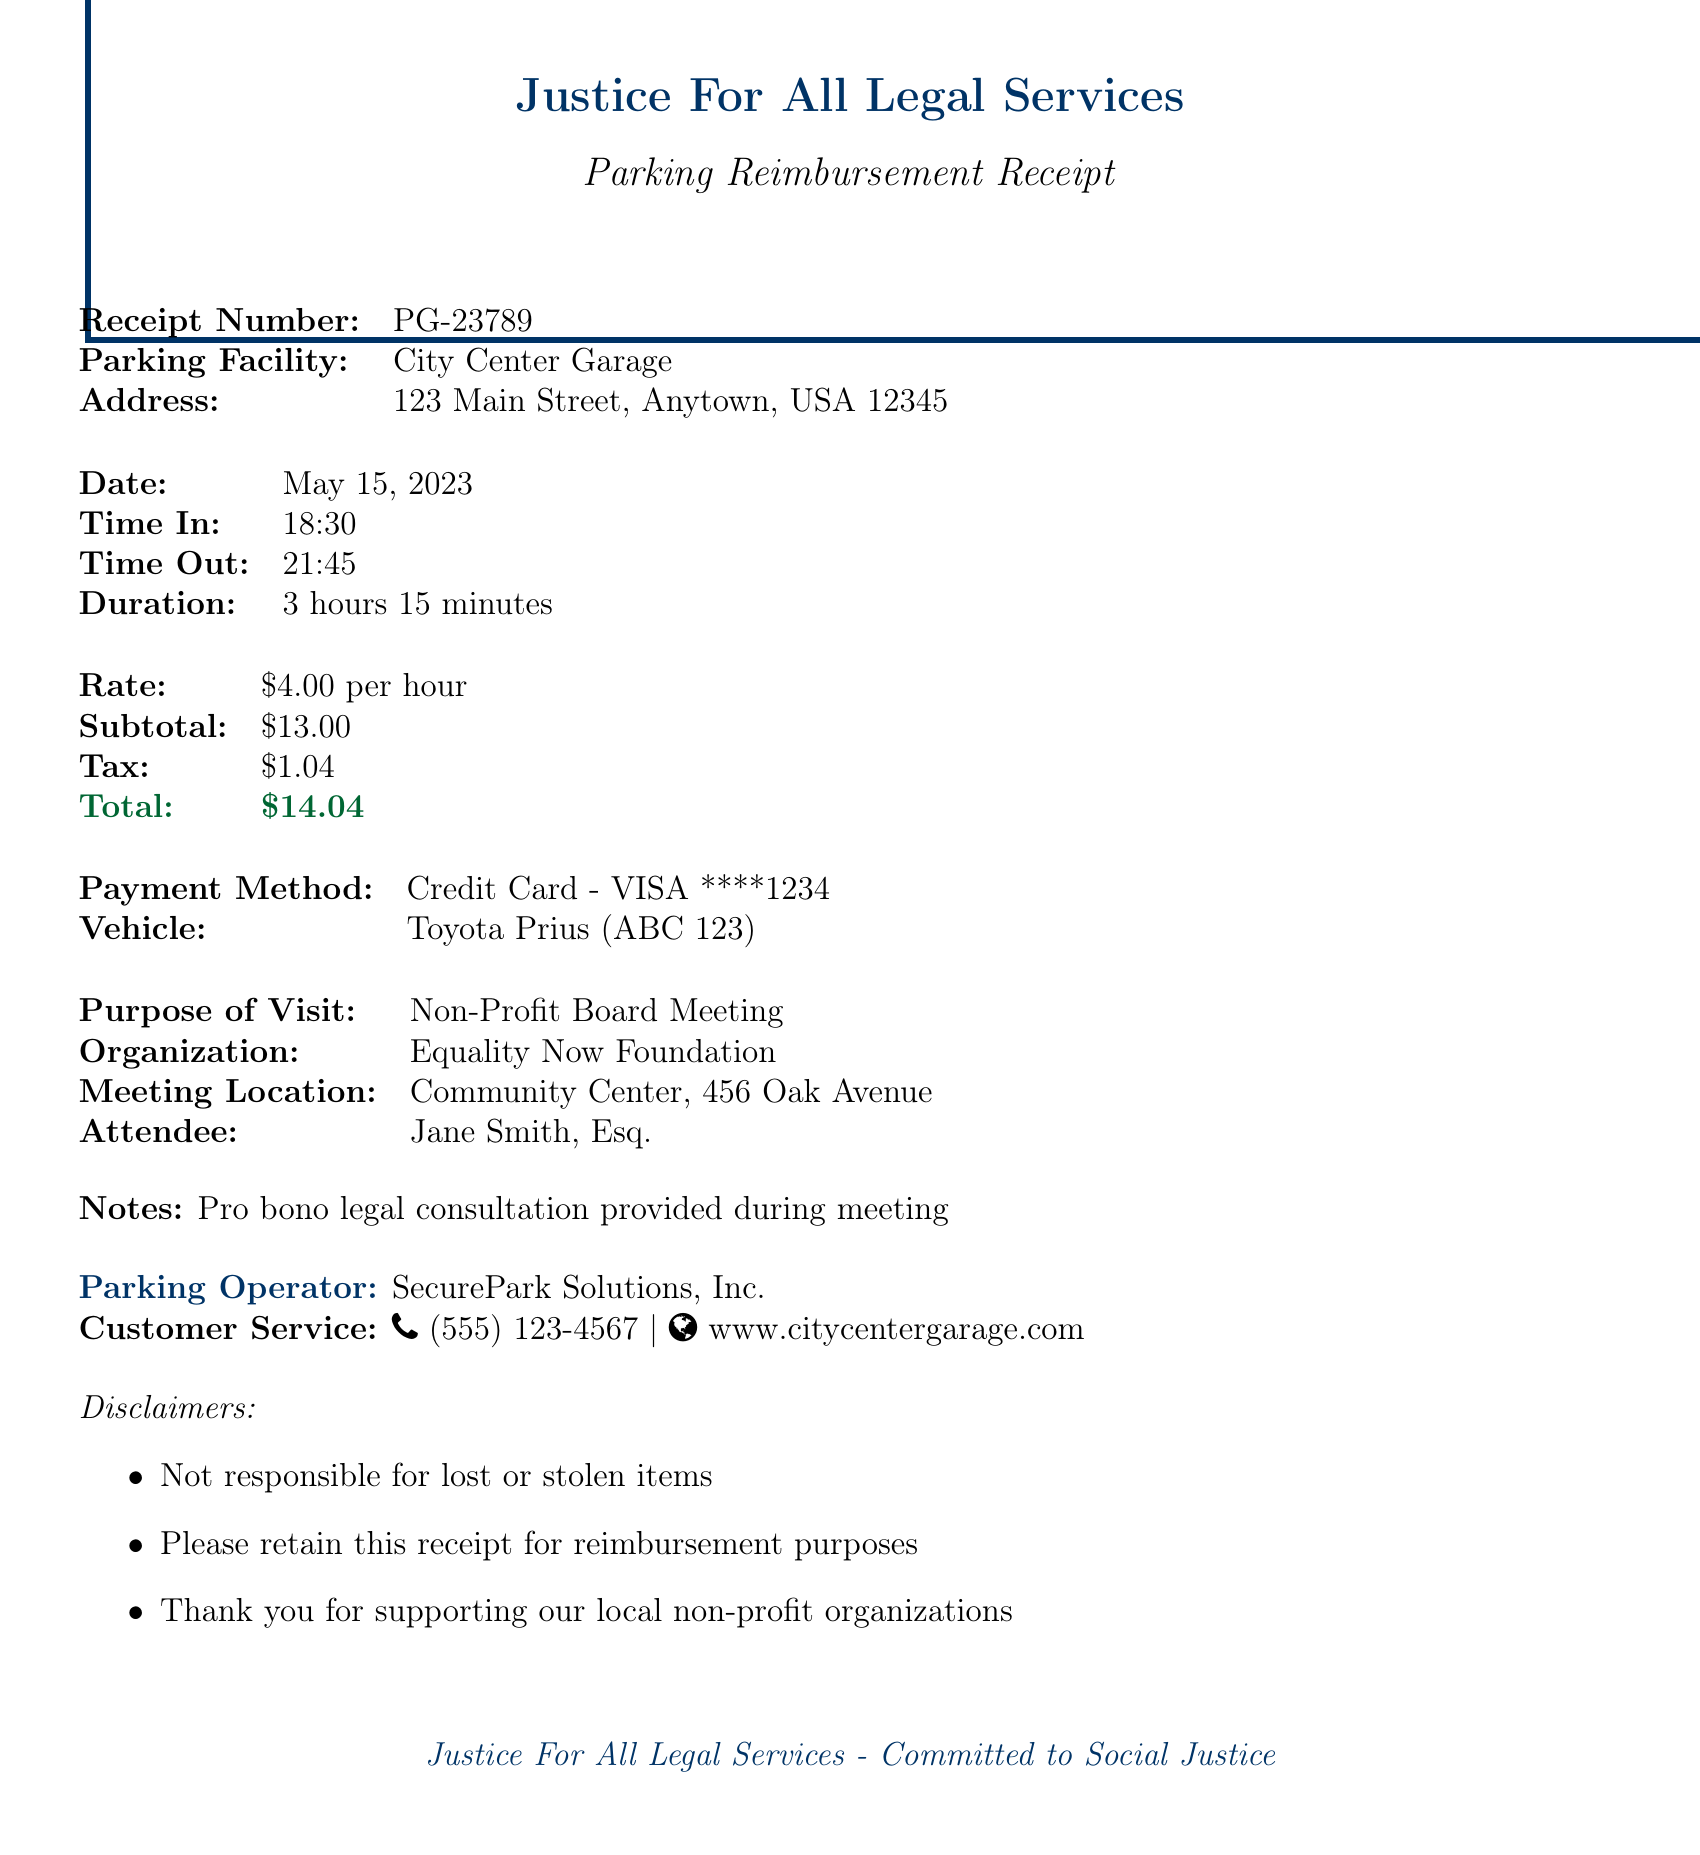What is the receipt number? The receipt number is a unique identifier for the transaction, which is PG-23789.
Answer: PG-23789 What is the parking facility's address? The address of the parking facility is provided in the document, located at 123 Main Street, Anytown, USA 12345.
Answer: 123 Main Street, Anytown, USA 12345 What was the duration of the parking? The duration indicates how long the vehicle was parked, which is 3 hours and 15 minutes as stated in the document.
Answer: 3 hours 15 minutes What was the total amount charged? The total amount charged includes both the subtotal and tax, which sums up to $14.04 as indicated in the receipt.
Answer: $14.04 What was the payment method used? The payment method reflects how the transaction was completed, which in this case was a Credit Card - VISA.
Answer: Credit Card - VISA ****1234 What organization was the attendee representing? The document specifies the name of the organization associated with the meeting attended by Jane Smith, which is the Equality Now Foundation.
Answer: Equality Now Foundation What is the purpose of the visit mentioned in the receipt? The purpose of the visit clarifies the reason for parking, which in this case was a Non-Profit Board Meeting.
Answer: Non-Profit Board Meeting Who provided the legal consultation during the meeting? The notes section states that a pro bono legal consultation was provided, indicating Jane Smith got involved.
Answer: Jane Smith How many minutes was the tax amount calculated based on? The document provides the duration of the parking for calculating the tax, which is 3 hours and 15 minutes overall.
Answer: 3 hours 15 minutes 